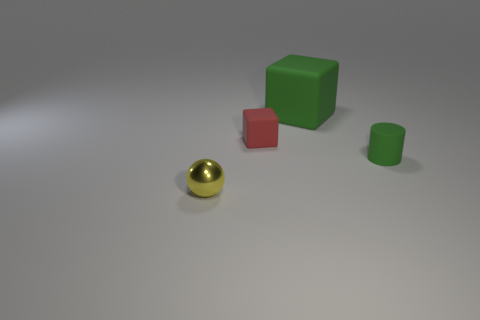Add 1 large rubber cubes. How many objects exist? 5 Subtract all cylinders. How many objects are left? 3 Subtract all big green rubber cubes. Subtract all metallic things. How many objects are left? 2 Add 4 small green things. How many small green things are left? 5 Add 3 big blue balls. How many big blue balls exist? 3 Subtract 0 red cylinders. How many objects are left? 4 